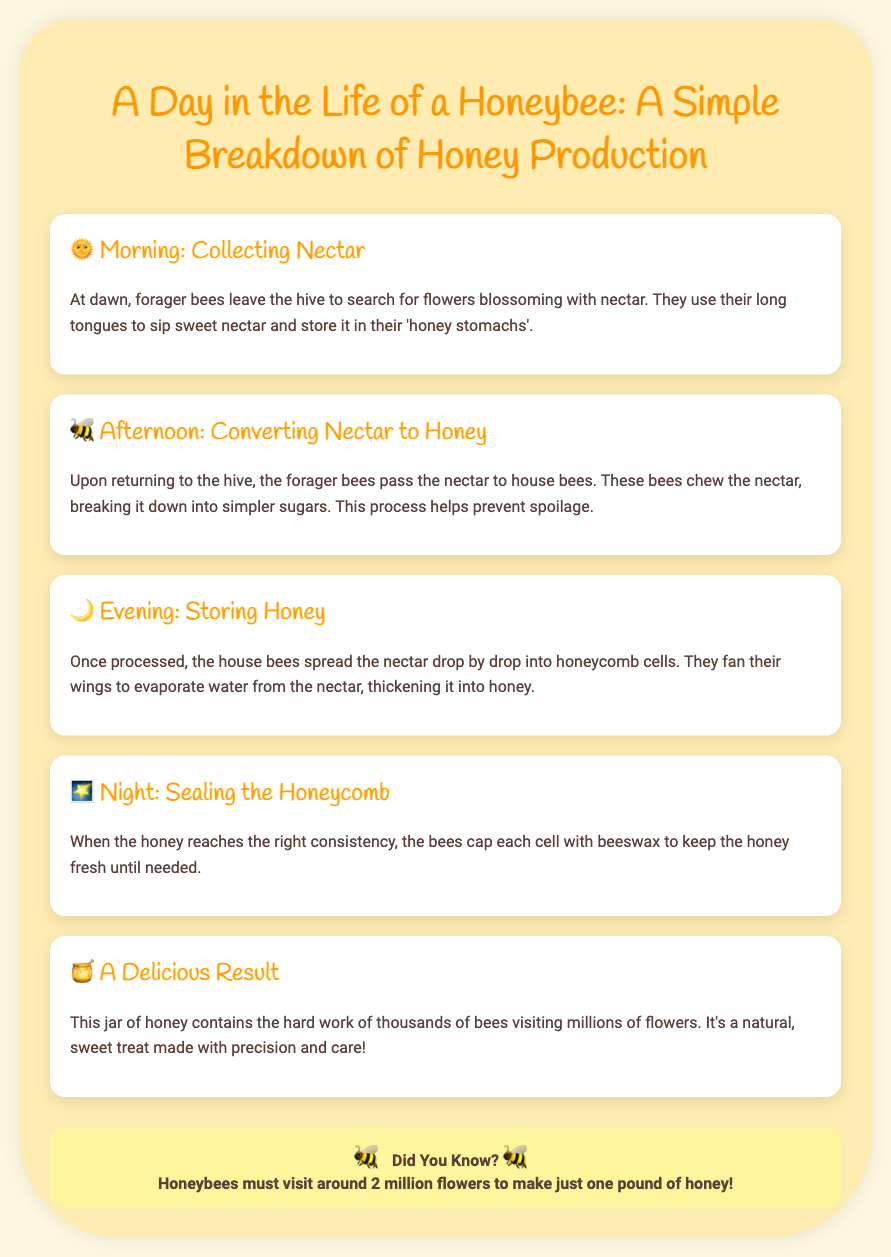What do forager bees collect in the morning? Forager bees leave the hive to search for flowers blossoming with nectar.
Answer: Nectar What do house bees do with the nectar? House bees chew the nectar, breaking it down into simpler sugars.
Answer: Chew What is used to cap the honeycomb? Bees cap each cell with beeswax to keep the honey fresh.
Answer: Beeswax How many flowers must honeybees visit to make one pound of honey? The document states that honeybees must visit around 2 million flowers for one pound of honey.
Answer: 2 million What is the result of a honeybee's hard work? The document describes the result as a natural, sweet treat made with precision and care.
Answer: Honey 